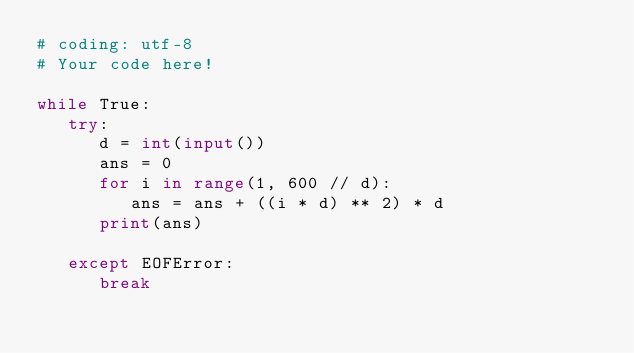<code> <loc_0><loc_0><loc_500><loc_500><_Python_># coding: utf-8
# Your code here!

while True:
   try:
      d = int(input())
      ans = 0
      for i in range(1, 600 // d):
         ans = ans + ((i * d) ** 2) * d
      print(ans)

   except EOFError:
      break

</code> 